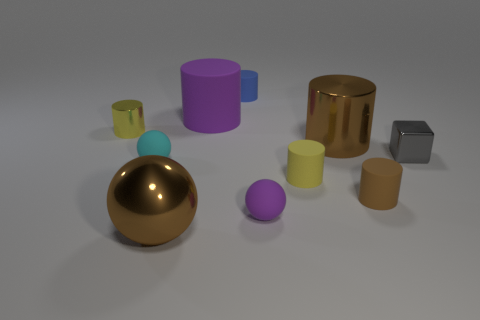Subtract all blue cylinders. How many cylinders are left? 5 Subtract all big brown metal cylinders. How many cylinders are left? 5 Subtract all blue cylinders. Subtract all gray spheres. How many cylinders are left? 5 Subtract all cylinders. How many objects are left? 4 Add 5 large green balls. How many large green balls exist? 5 Subtract 1 gray cubes. How many objects are left? 9 Subtract all large brown metallic spheres. Subtract all green metallic cylinders. How many objects are left? 9 Add 5 tiny yellow rubber cylinders. How many tiny yellow rubber cylinders are left? 6 